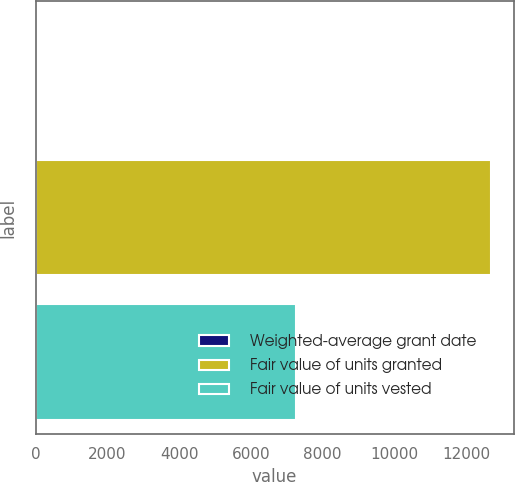Convert chart. <chart><loc_0><loc_0><loc_500><loc_500><bar_chart><fcel>Weighted-average grant date<fcel>Fair value of units granted<fcel>Fair value of units vested<nl><fcel>45.11<fcel>12685<fcel>7258<nl></chart> 